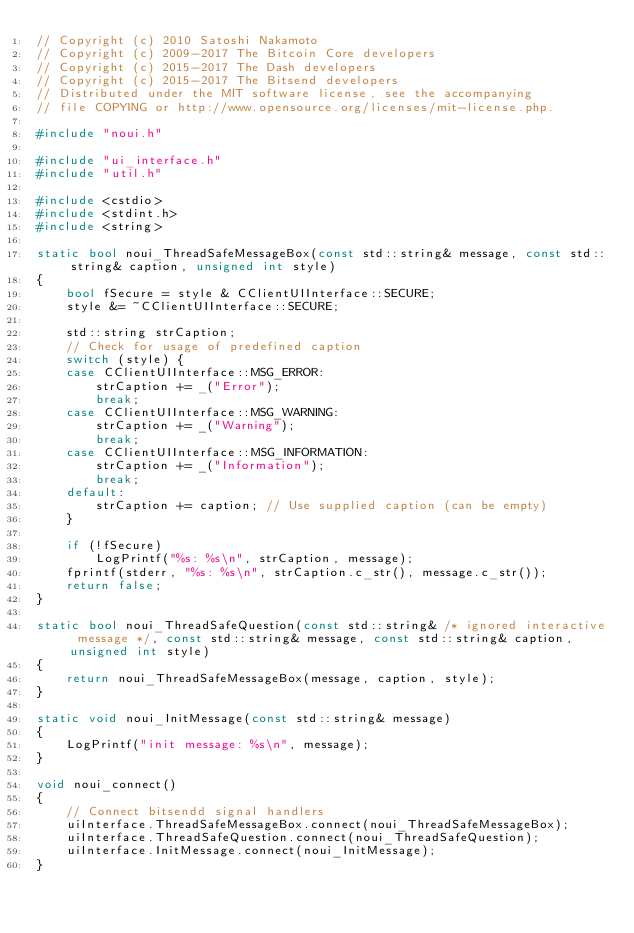Convert code to text. <code><loc_0><loc_0><loc_500><loc_500><_C++_>// Copyright (c) 2010 Satoshi Nakamoto
// Copyright (c) 2009-2017 The Bitcoin Core developers 
// Copyright (c) 2015-2017 The Dash developers 
// Copyright (c) 2015-2017 The Bitsend developers
// Distributed under the MIT software license, see the accompanying
// file COPYING or http://www.opensource.org/licenses/mit-license.php.

#include "noui.h"

#include "ui_interface.h"
#include "util.h"

#include <cstdio>
#include <stdint.h>
#include <string>

static bool noui_ThreadSafeMessageBox(const std::string& message, const std::string& caption, unsigned int style)
{
    bool fSecure = style & CClientUIInterface::SECURE;
    style &= ~CClientUIInterface::SECURE;

    std::string strCaption;
    // Check for usage of predefined caption
    switch (style) {
    case CClientUIInterface::MSG_ERROR:
        strCaption += _("Error");
        break;
    case CClientUIInterface::MSG_WARNING:
        strCaption += _("Warning");
        break;
    case CClientUIInterface::MSG_INFORMATION:
        strCaption += _("Information");
        break;
    default:
        strCaption += caption; // Use supplied caption (can be empty)
    }

    if (!fSecure)
        LogPrintf("%s: %s\n", strCaption, message);
    fprintf(stderr, "%s: %s\n", strCaption.c_str(), message.c_str());
    return false;
}

static bool noui_ThreadSafeQuestion(const std::string& /* ignored interactive message */, const std::string& message, const std::string& caption, unsigned int style)
{
    return noui_ThreadSafeMessageBox(message, caption, style);
}

static void noui_InitMessage(const std::string& message)
{
    LogPrintf("init message: %s\n", message);
}

void noui_connect()
{
    // Connect bitsendd signal handlers
    uiInterface.ThreadSafeMessageBox.connect(noui_ThreadSafeMessageBox);
    uiInterface.ThreadSafeQuestion.connect(noui_ThreadSafeQuestion);
    uiInterface.InitMessage.connect(noui_InitMessage);
}
</code> 